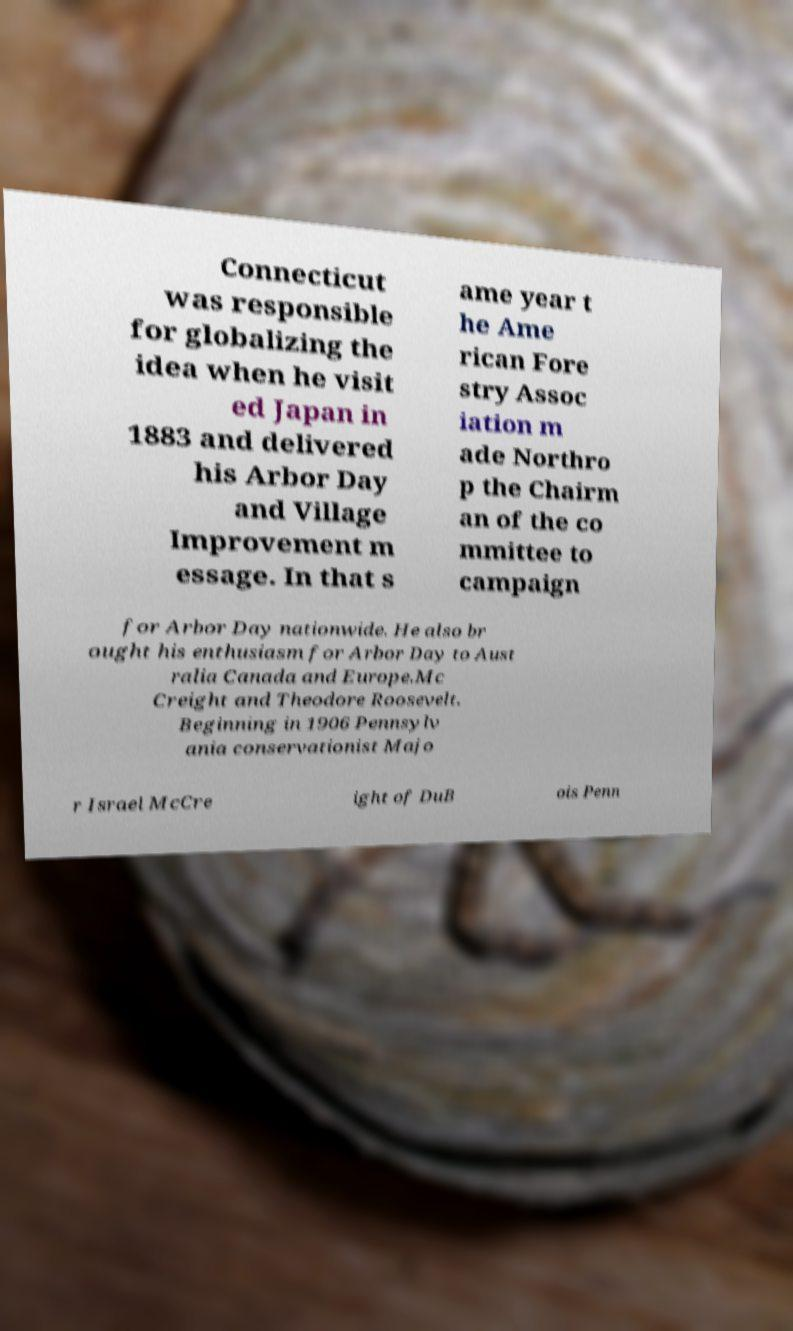There's text embedded in this image that I need extracted. Can you transcribe it verbatim? Connecticut was responsible for globalizing the idea when he visit ed Japan in 1883 and delivered his Arbor Day and Village Improvement m essage. In that s ame year t he Ame rican Fore stry Assoc iation m ade Northro p the Chairm an of the co mmittee to campaign for Arbor Day nationwide. He also br ought his enthusiasm for Arbor Day to Aust ralia Canada and Europe.Mc Creight and Theodore Roosevelt. Beginning in 1906 Pennsylv ania conservationist Majo r Israel McCre ight of DuB ois Penn 